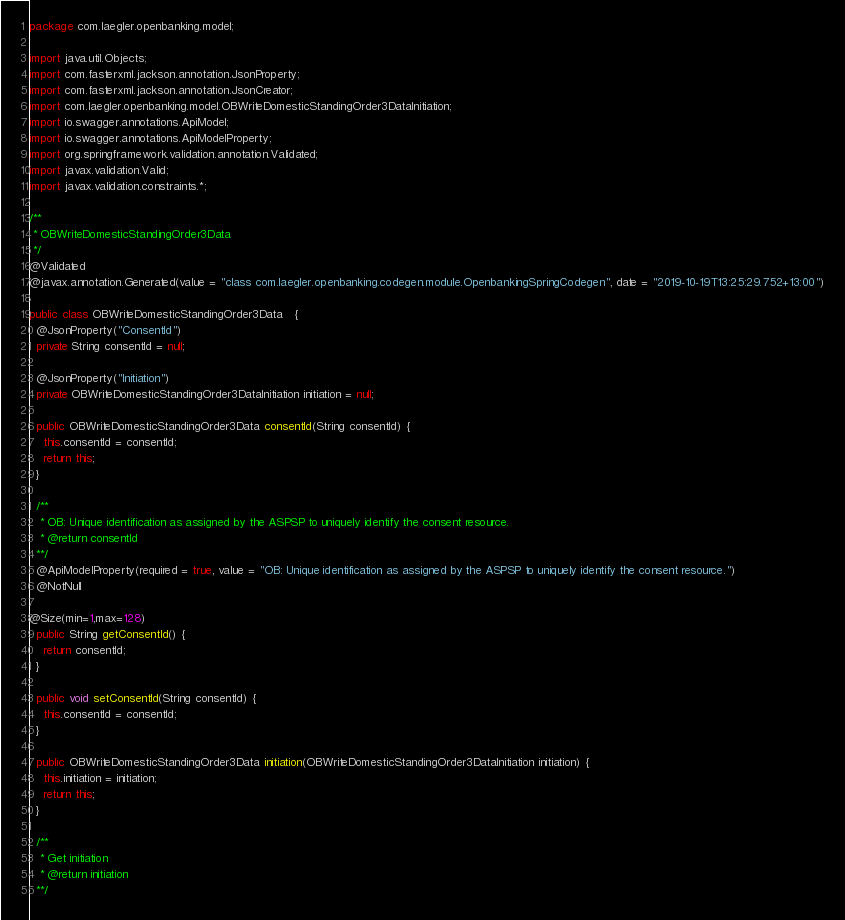<code> <loc_0><loc_0><loc_500><loc_500><_Java_>package com.laegler.openbanking.model;

import java.util.Objects;
import com.fasterxml.jackson.annotation.JsonProperty;
import com.fasterxml.jackson.annotation.JsonCreator;
import com.laegler.openbanking.model.OBWriteDomesticStandingOrder3DataInitiation;
import io.swagger.annotations.ApiModel;
import io.swagger.annotations.ApiModelProperty;
import org.springframework.validation.annotation.Validated;
import javax.validation.Valid;
import javax.validation.constraints.*;

/**
 * OBWriteDomesticStandingOrder3Data
 */
@Validated
@javax.annotation.Generated(value = "class com.laegler.openbanking.codegen.module.OpenbankingSpringCodegen", date = "2019-10-19T13:25:29.752+13:00")

public class OBWriteDomesticStandingOrder3Data   {
  @JsonProperty("ConsentId")
  private String consentId = null;

  @JsonProperty("Initiation")
  private OBWriteDomesticStandingOrder3DataInitiation initiation = null;

  public OBWriteDomesticStandingOrder3Data consentId(String consentId) {
    this.consentId = consentId;
    return this;
  }

  /**
   * OB: Unique identification as assigned by the ASPSP to uniquely identify the consent resource.
   * @return consentId
  **/
  @ApiModelProperty(required = true, value = "OB: Unique identification as assigned by the ASPSP to uniquely identify the consent resource.")
  @NotNull

@Size(min=1,max=128) 
  public String getConsentId() {
    return consentId;
  }

  public void setConsentId(String consentId) {
    this.consentId = consentId;
  }

  public OBWriteDomesticStandingOrder3Data initiation(OBWriteDomesticStandingOrder3DataInitiation initiation) {
    this.initiation = initiation;
    return this;
  }

  /**
   * Get initiation
   * @return initiation
  **/</code> 